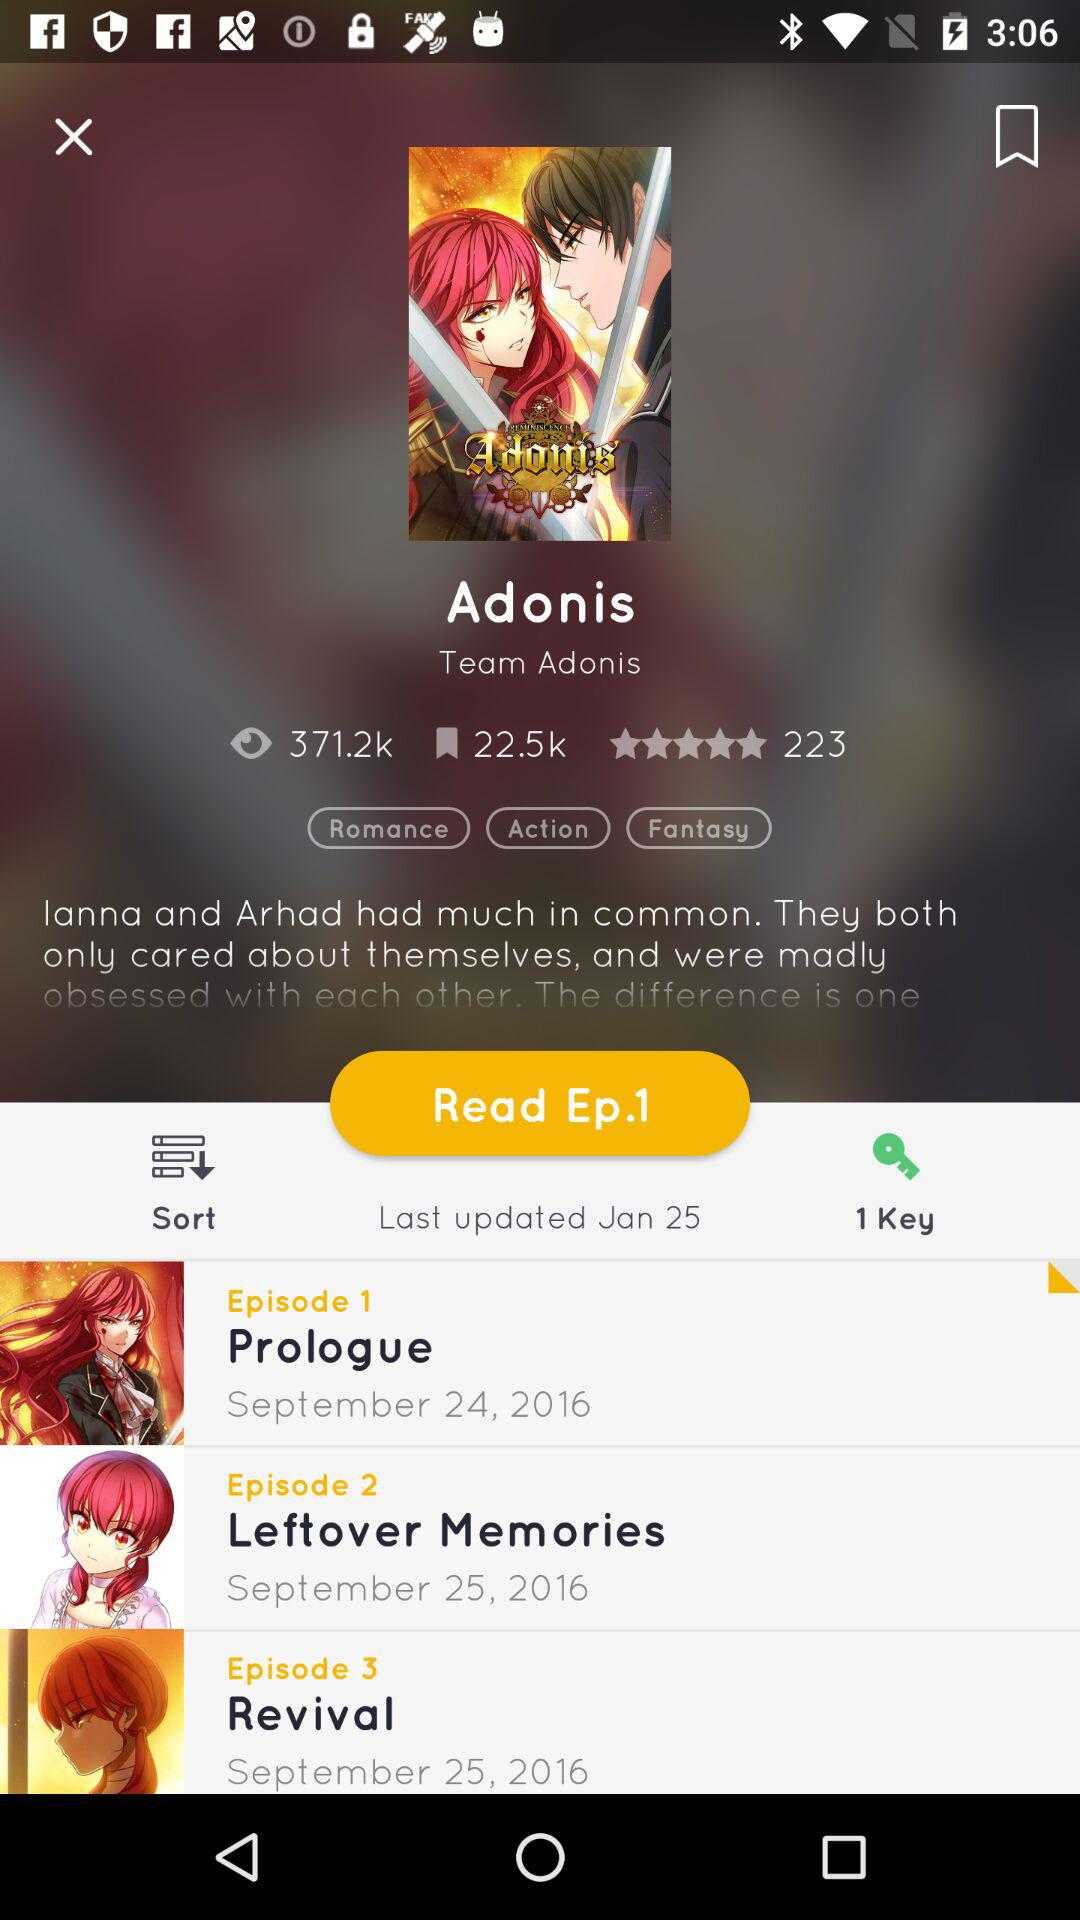How many views are there? There are 371.2k views. 